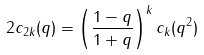<formula> <loc_0><loc_0><loc_500><loc_500>2 c _ { 2 k } ( q ) = \left ( \frac { 1 - q } { 1 + q } \right ) ^ { k } c _ { k } ( q ^ { 2 } )</formula> 